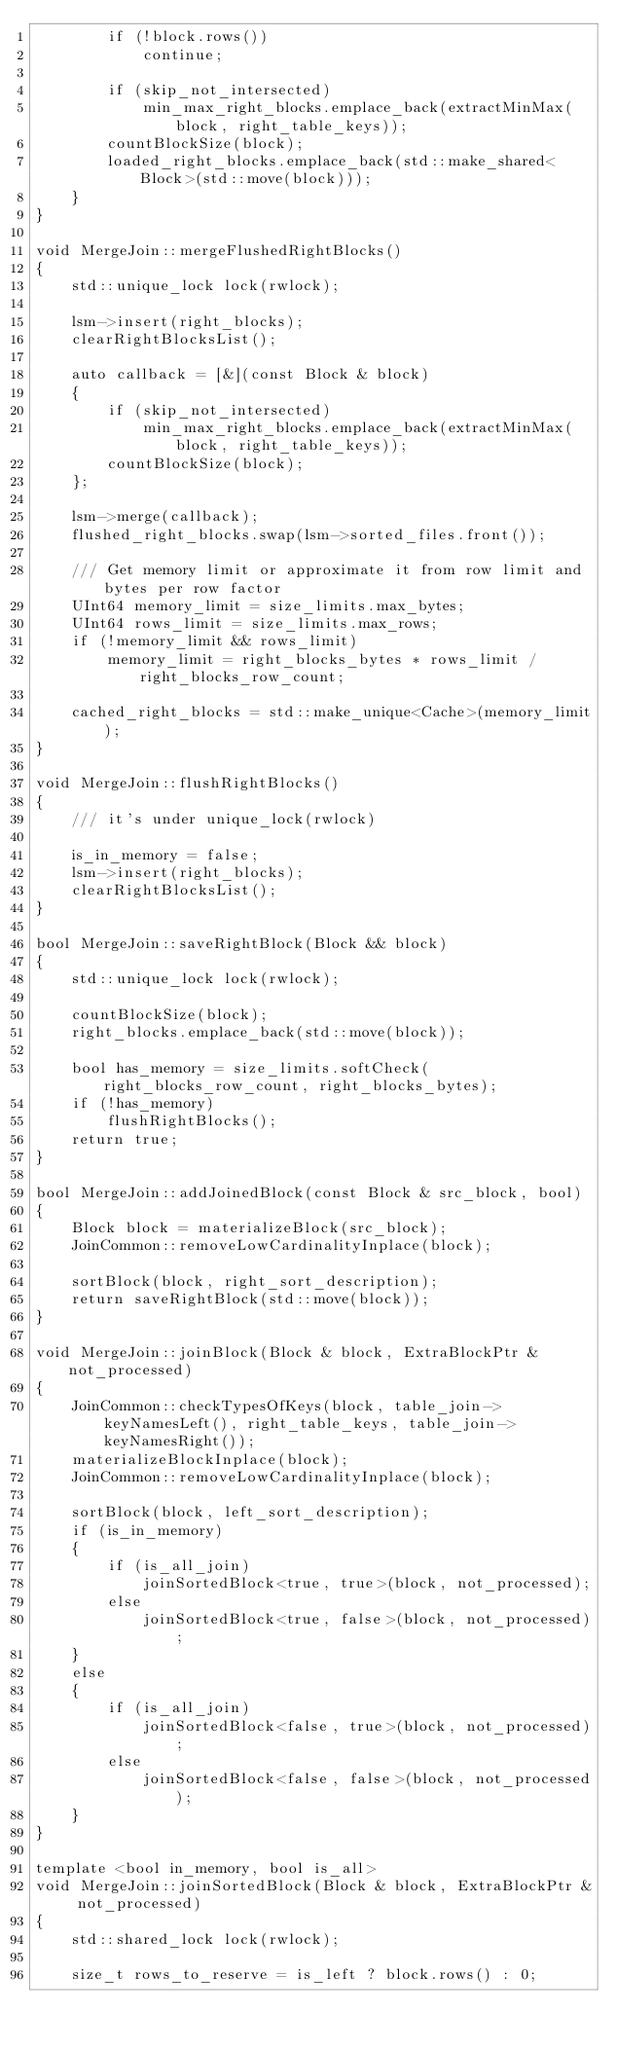<code> <loc_0><loc_0><loc_500><loc_500><_C++_>        if (!block.rows())
            continue;

        if (skip_not_intersected)
            min_max_right_blocks.emplace_back(extractMinMax(block, right_table_keys));
        countBlockSize(block);
        loaded_right_blocks.emplace_back(std::make_shared<Block>(std::move(block)));
    }
}

void MergeJoin::mergeFlushedRightBlocks()
{
    std::unique_lock lock(rwlock);

    lsm->insert(right_blocks);
    clearRightBlocksList();

    auto callback = [&](const Block & block)
    {
        if (skip_not_intersected)
            min_max_right_blocks.emplace_back(extractMinMax(block, right_table_keys));
        countBlockSize(block);
    };

    lsm->merge(callback);
    flushed_right_blocks.swap(lsm->sorted_files.front());

    /// Get memory limit or approximate it from row limit and bytes per row factor
    UInt64 memory_limit = size_limits.max_bytes;
    UInt64 rows_limit = size_limits.max_rows;
    if (!memory_limit && rows_limit)
        memory_limit = right_blocks_bytes * rows_limit / right_blocks_row_count;

    cached_right_blocks = std::make_unique<Cache>(memory_limit);
}

void MergeJoin::flushRightBlocks()
{
    /// it's under unique_lock(rwlock)

    is_in_memory = false;
    lsm->insert(right_blocks);
    clearRightBlocksList();
}

bool MergeJoin::saveRightBlock(Block && block)
{
    std::unique_lock lock(rwlock);

    countBlockSize(block);
    right_blocks.emplace_back(std::move(block));

    bool has_memory = size_limits.softCheck(right_blocks_row_count, right_blocks_bytes);
    if (!has_memory)
        flushRightBlocks();
    return true;
}

bool MergeJoin::addJoinedBlock(const Block & src_block, bool)
{
    Block block = materializeBlock(src_block);
    JoinCommon::removeLowCardinalityInplace(block);

    sortBlock(block, right_sort_description);
    return saveRightBlock(std::move(block));
}

void MergeJoin::joinBlock(Block & block, ExtraBlockPtr & not_processed)
{
    JoinCommon::checkTypesOfKeys(block, table_join->keyNamesLeft(), right_table_keys, table_join->keyNamesRight());
    materializeBlockInplace(block);
    JoinCommon::removeLowCardinalityInplace(block);

    sortBlock(block, left_sort_description);
    if (is_in_memory)
    {
        if (is_all_join)
            joinSortedBlock<true, true>(block, not_processed);
        else
            joinSortedBlock<true, false>(block, not_processed);
    }
    else
    {
        if (is_all_join)
            joinSortedBlock<false, true>(block, not_processed);
        else
            joinSortedBlock<false, false>(block, not_processed);
    }
}

template <bool in_memory, bool is_all>
void MergeJoin::joinSortedBlock(Block & block, ExtraBlockPtr & not_processed)
{
    std::shared_lock lock(rwlock);

    size_t rows_to_reserve = is_left ? block.rows() : 0;</code> 